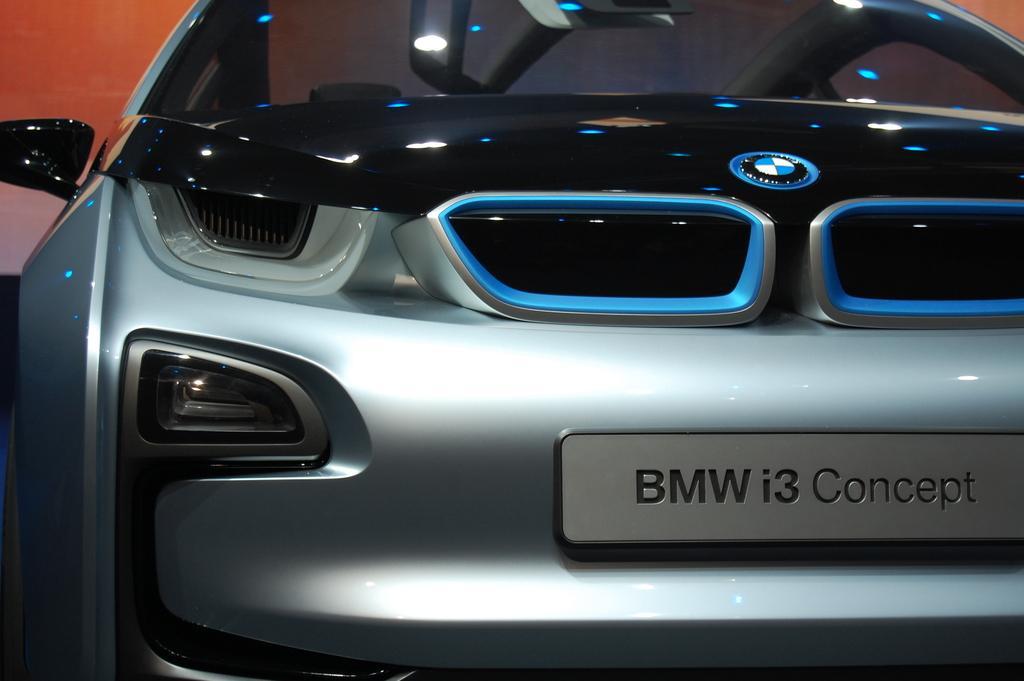Could you give a brief overview of what you see in this image? This is the image of a car. There is a registration plate at the front on which ''bmw i3 concept'' is written. There is an orange background. 